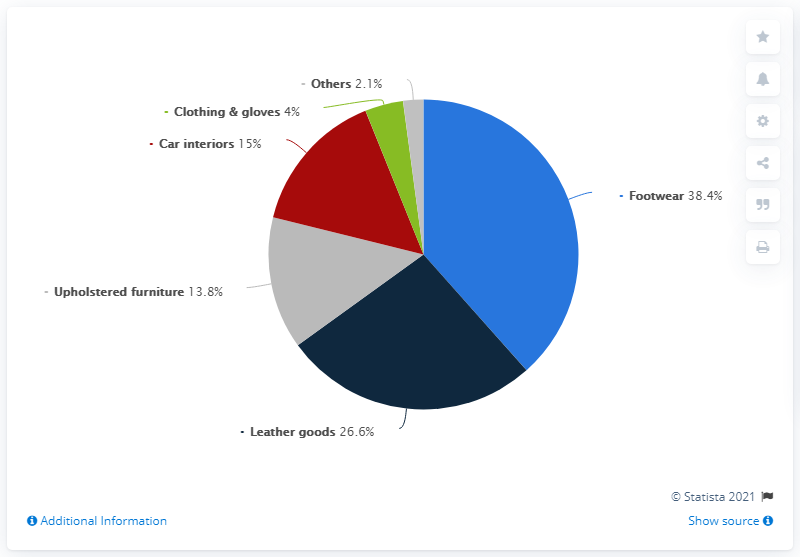Give some essential details in this illustration. If we add blue and dark blue bars, we will obtain a percentage that is equivalent to 65%. The percentage shown for footwear is 38.4%. In 2018, the production of leather for footwear decreased by 38.4% compared to the previous year. In 2018, approximately 38.4% of Italy's leather tanning industry was dedicated to the production of leather for footwear. 